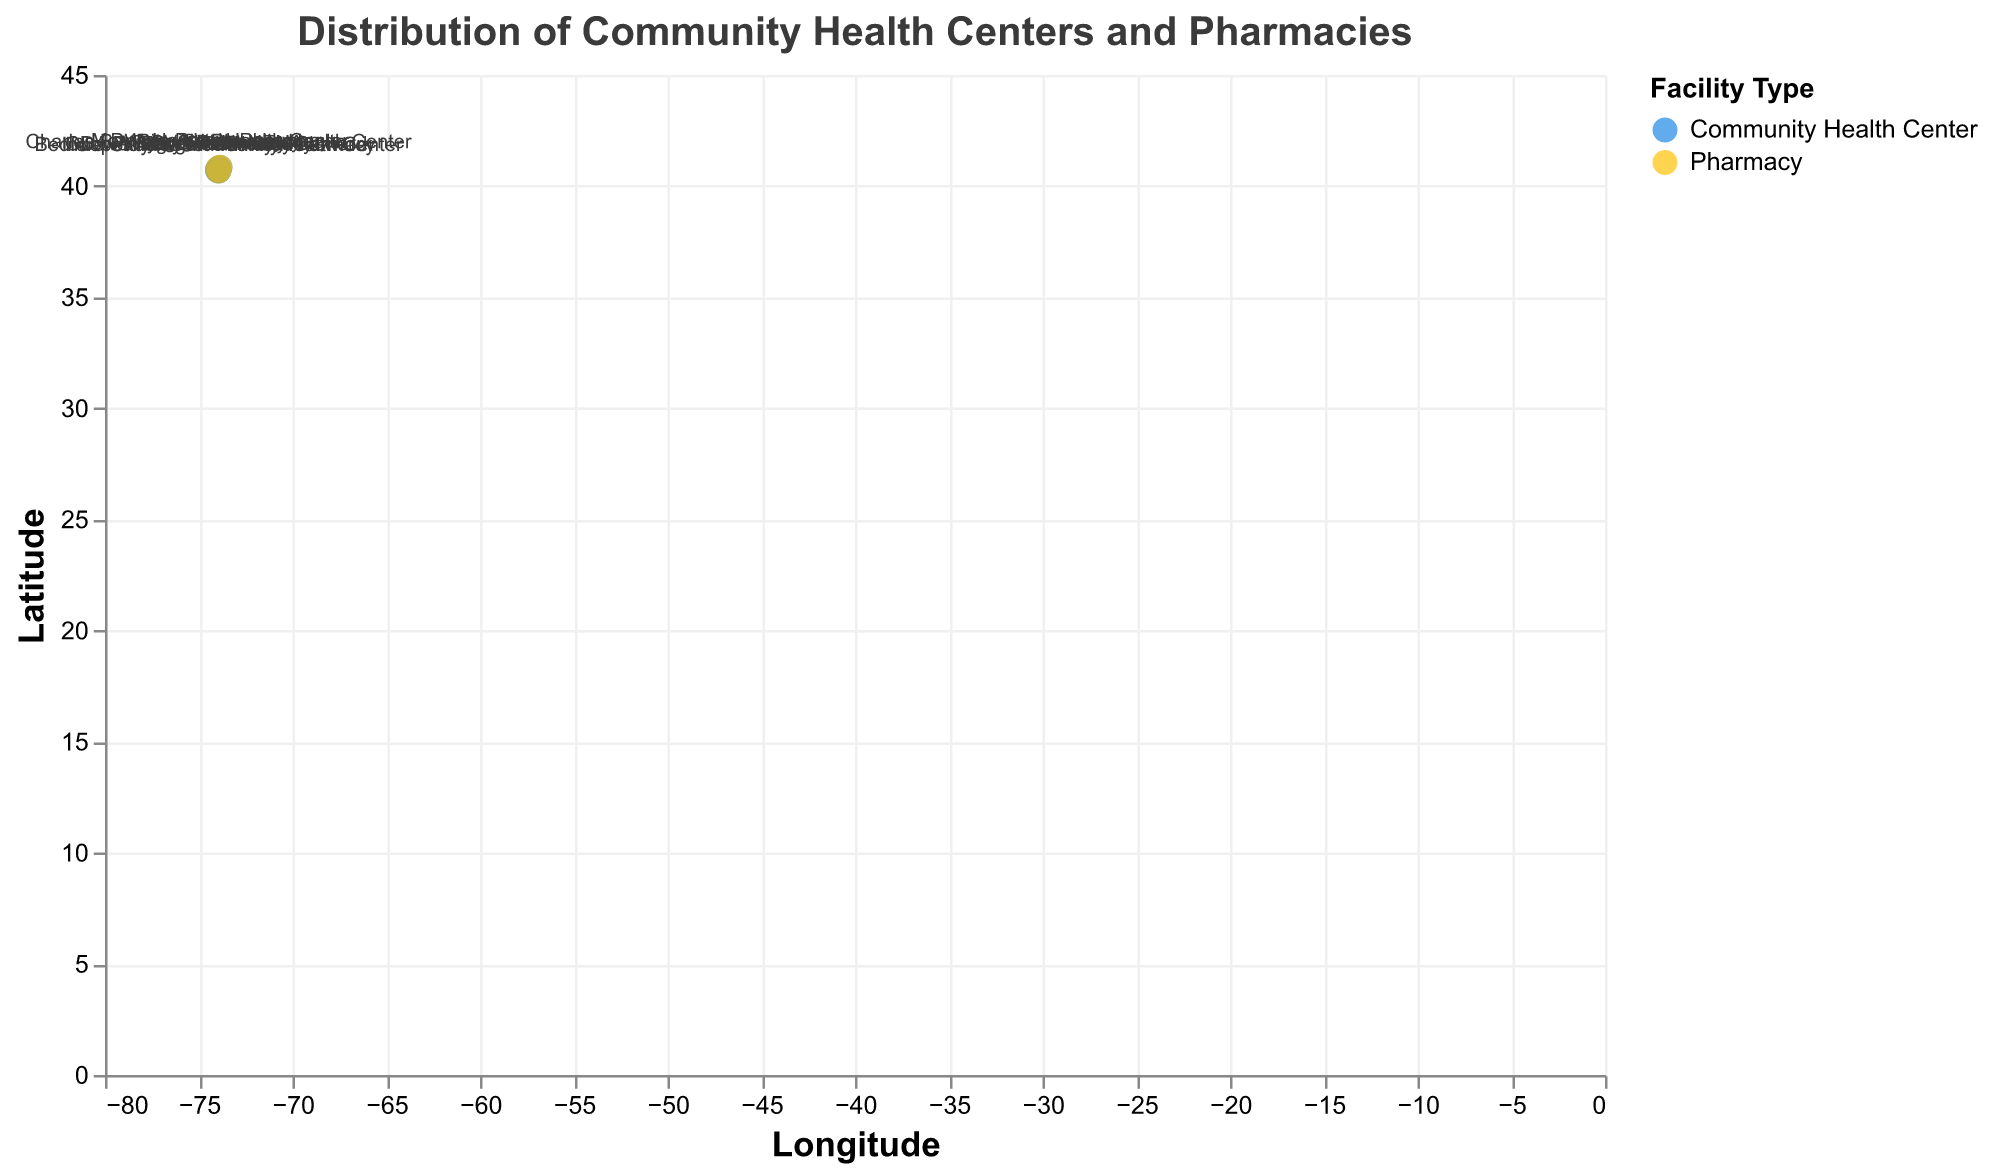What is the title of the plotted figure? The title is displayed at the top of the figure and indicates the overall subject of the visualization. The title of the figure is "Distribution of Community Health Centers and Pharmacies."
Answer: Distribution of Community Health Centers and Pharmacies How many Community Health Centers are plotted on the map? By looking at the color legend and counting the blue circles on the map, we can determine the number of Community Health Centers. There are 6 Community Health Centers plotted on the map.
Answer: 6 What is the latitude and longitude of Bedford Stuyvesant Family Health Center? The position of Bedford Stuyvesant Family Health Center can be identified by locating its name label on the map. Its coordinates are given as Latitude: 40.6782 and Longitude: -73.9442.
Answer: Latitude: 40.6782, Longitude: -73.9442 Which Community Health Center is closest to a pharmacy, and how far is it from that pharmacy? By checking the "Distance_to_Pharmacy_miles" tooltip for all Community Health Centers, we find that the Charles B. Wang Community Health Center has the shortest distance to a pharmacy at 0.2 miles.
Answer: Charles B. Wang Community Health Center, 0.2 miles Is there any pharmacy located exactly at the same latitude and longitude as a Community Health Center? We can check each pharmacy and Community Health Center to see if any have identical coordinates. Rite Aid Pharmacy and Charles B. Wang Community Health Center share the same latitude and longitude: (40.8075, -73.9465).
Answer: Yes, Rite Aid Pharmacy and Charles B. Wang Community Health Center Compare the proximity of Ryan Health NENA and ODA Primary Health Care Network to their nearest pharmacies. Which one has a shorter distance to a pharmacy? Ryan Health NENA is 0.5 miles from its nearest pharmacy, while ODA Primary Health Care Network is 0.6 miles from its nearest pharmacy. Therefore, Ryan Health NENA is closer to its nearest pharmacy than ODA Primary Health Care Network.
Answer: Ryan Health NENA Which quadrant of the map (NE, NW, SE, SW) has the most Community Health Centers? By dividing the map into quadrants based on the latitude and longitude axes, we can count the Community Health Centers in each quadrant. The NW quadrant (top-left) has the most Community Health Centers with three: Charles B. Wang Community Health Center, Morris Heights Health Center, and Ryan Health NENA.
Answer: NW quadrant What is the average distance to the nearest pharmacy for all Community Health Centers? To calculate the average distance, sum the distances of all Community Health Centers to their nearest pharmacies and divide by the number of centers. The distances are: 0.3, 0.5, 0.2, 0.7, 0.4, 0.6; the sum is 2.7 miles. Divide by 6 (number of centers) to get the average distance, which is 2.7 / 6 = 0.45 miles.
Answer: 0.45 miles 